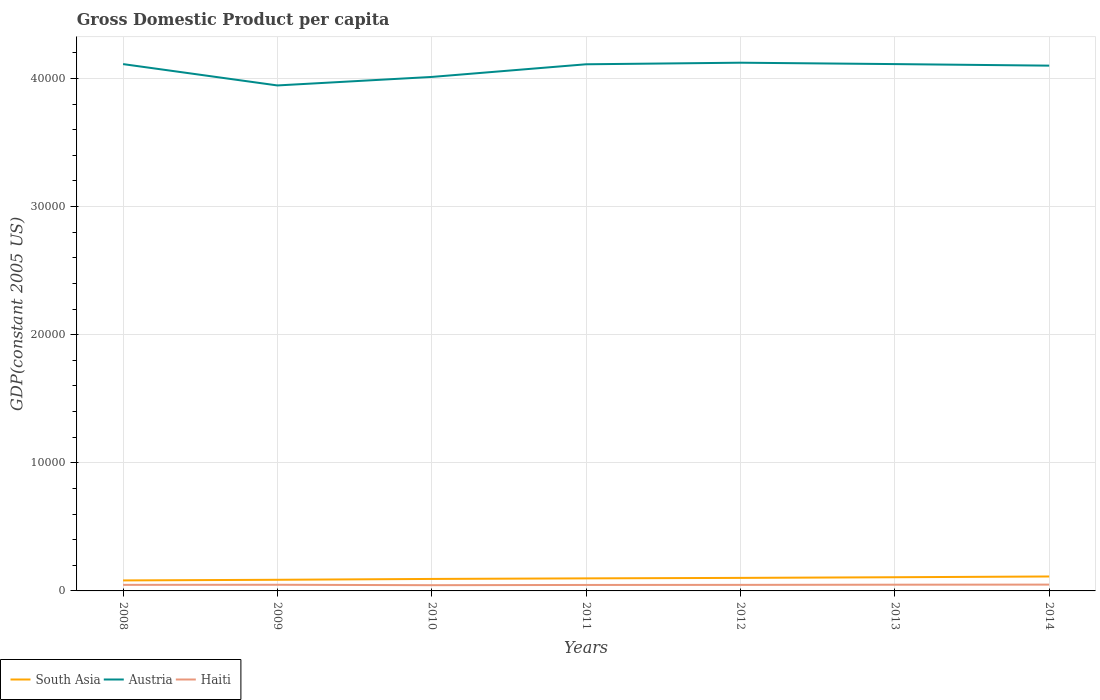Is the number of lines equal to the number of legend labels?
Your response must be concise. Yes. Across all years, what is the maximum GDP per capita in Austria?
Your response must be concise. 3.95e+04. What is the total GDP per capita in Austria in the graph?
Offer a terse response. -1666.59. What is the difference between the highest and the second highest GDP per capita in South Asia?
Your answer should be compact. 306.79. What is the difference between the highest and the lowest GDP per capita in Haiti?
Provide a succinct answer. 3. How many lines are there?
Make the answer very short. 3. Are the values on the major ticks of Y-axis written in scientific E-notation?
Give a very brief answer. No. Does the graph contain grids?
Give a very brief answer. Yes. Where does the legend appear in the graph?
Provide a succinct answer. Bottom left. How many legend labels are there?
Your response must be concise. 3. What is the title of the graph?
Offer a terse response. Gross Domestic Product per capita. Does "Andorra" appear as one of the legend labels in the graph?
Offer a very short reply. No. What is the label or title of the X-axis?
Offer a very short reply. Years. What is the label or title of the Y-axis?
Your response must be concise. GDP(constant 2005 US). What is the GDP(constant 2005 US) in South Asia in 2008?
Offer a very short reply. 819.76. What is the GDP(constant 2005 US) in Austria in 2008?
Ensure brevity in your answer.  4.11e+04. What is the GDP(constant 2005 US) in Haiti in 2008?
Make the answer very short. 473.28. What is the GDP(constant 2005 US) in South Asia in 2009?
Your answer should be compact. 869.5. What is the GDP(constant 2005 US) of Austria in 2009?
Provide a succinct answer. 3.95e+04. What is the GDP(constant 2005 US) of Haiti in 2009?
Provide a short and direct response. 480.56. What is the GDP(constant 2005 US) of South Asia in 2010?
Ensure brevity in your answer.  934.8. What is the GDP(constant 2005 US) in Austria in 2010?
Give a very brief answer. 4.01e+04. What is the GDP(constant 2005 US) of Haiti in 2010?
Your answer should be very brief. 447.47. What is the GDP(constant 2005 US) of South Asia in 2011?
Keep it short and to the point. 979.83. What is the GDP(constant 2005 US) in Austria in 2011?
Provide a short and direct response. 4.11e+04. What is the GDP(constant 2005 US) of Haiti in 2011?
Offer a terse response. 465.43. What is the GDP(constant 2005 US) of South Asia in 2012?
Your answer should be compact. 1016.87. What is the GDP(constant 2005 US) in Austria in 2012?
Your answer should be very brief. 4.12e+04. What is the GDP(constant 2005 US) of Haiti in 2012?
Offer a terse response. 472.16. What is the GDP(constant 2005 US) in South Asia in 2013?
Keep it short and to the point. 1068.23. What is the GDP(constant 2005 US) of Austria in 2013?
Give a very brief answer. 4.11e+04. What is the GDP(constant 2005 US) of Haiti in 2013?
Give a very brief answer. 485.5. What is the GDP(constant 2005 US) of South Asia in 2014?
Offer a very short reply. 1126.55. What is the GDP(constant 2005 US) in Austria in 2014?
Give a very brief answer. 4.10e+04. What is the GDP(constant 2005 US) in Haiti in 2014?
Give a very brief answer. 492.2. Across all years, what is the maximum GDP(constant 2005 US) of South Asia?
Your answer should be compact. 1126.55. Across all years, what is the maximum GDP(constant 2005 US) of Austria?
Make the answer very short. 4.12e+04. Across all years, what is the maximum GDP(constant 2005 US) in Haiti?
Your answer should be very brief. 492.2. Across all years, what is the minimum GDP(constant 2005 US) of South Asia?
Offer a terse response. 819.76. Across all years, what is the minimum GDP(constant 2005 US) in Austria?
Give a very brief answer. 3.95e+04. Across all years, what is the minimum GDP(constant 2005 US) in Haiti?
Ensure brevity in your answer.  447.47. What is the total GDP(constant 2005 US) of South Asia in the graph?
Make the answer very short. 6815.54. What is the total GDP(constant 2005 US) of Austria in the graph?
Offer a very short reply. 2.85e+05. What is the total GDP(constant 2005 US) in Haiti in the graph?
Give a very brief answer. 3316.6. What is the difference between the GDP(constant 2005 US) in South Asia in 2008 and that in 2009?
Offer a very short reply. -49.74. What is the difference between the GDP(constant 2005 US) of Austria in 2008 and that in 2009?
Keep it short and to the point. 1665.68. What is the difference between the GDP(constant 2005 US) of Haiti in 2008 and that in 2009?
Make the answer very short. -7.27. What is the difference between the GDP(constant 2005 US) in South Asia in 2008 and that in 2010?
Ensure brevity in your answer.  -115.04. What is the difference between the GDP(constant 2005 US) of Austria in 2008 and that in 2010?
Offer a terse response. 1001.29. What is the difference between the GDP(constant 2005 US) in Haiti in 2008 and that in 2010?
Ensure brevity in your answer.  25.81. What is the difference between the GDP(constant 2005 US) in South Asia in 2008 and that in 2011?
Provide a succinct answer. -160.07. What is the difference between the GDP(constant 2005 US) in Austria in 2008 and that in 2011?
Offer a terse response. 13.54. What is the difference between the GDP(constant 2005 US) in Haiti in 2008 and that in 2011?
Your response must be concise. 7.85. What is the difference between the GDP(constant 2005 US) of South Asia in 2008 and that in 2012?
Ensure brevity in your answer.  -197.11. What is the difference between the GDP(constant 2005 US) in Austria in 2008 and that in 2012?
Provide a succinct answer. -109.35. What is the difference between the GDP(constant 2005 US) of Haiti in 2008 and that in 2012?
Keep it short and to the point. 1.12. What is the difference between the GDP(constant 2005 US) of South Asia in 2008 and that in 2013?
Your response must be concise. -248.47. What is the difference between the GDP(constant 2005 US) of Austria in 2008 and that in 2013?
Your response must be concise. -0.91. What is the difference between the GDP(constant 2005 US) of Haiti in 2008 and that in 2013?
Offer a terse response. -12.21. What is the difference between the GDP(constant 2005 US) of South Asia in 2008 and that in 2014?
Provide a short and direct response. -306.79. What is the difference between the GDP(constant 2005 US) of Austria in 2008 and that in 2014?
Your response must be concise. 120.24. What is the difference between the GDP(constant 2005 US) of Haiti in 2008 and that in 2014?
Provide a short and direct response. -18.92. What is the difference between the GDP(constant 2005 US) in South Asia in 2009 and that in 2010?
Make the answer very short. -65.31. What is the difference between the GDP(constant 2005 US) in Austria in 2009 and that in 2010?
Keep it short and to the point. -664.39. What is the difference between the GDP(constant 2005 US) in Haiti in 2009 and that in 2010?
Make the answer very short. 33.08. What is the difference between the GDP(constant 2005 US) of South Asia in 2009 and that in 2011?
Your answer should be very brief. -110.34. What is the difference between the GDP(constant 2005 US) of Austria in 2009 and that in 2011?
Ensure brevity in your answer.  -1652.14. What is the difference between the GDP(constant 2005 US) in Haiti in 2009 and that in 2011?
Make the answer very short. 15.13. What is the difference between the GDP(constant 2005 US) in South Asia in 2009 and that in 2012?
Your response must be concise. -147.37. What is the difference between the GDP(constant 2005 US) in Austria in 2009 and that in 2012?
Keep it short and to the point. -1775.04. What is the difference between the GDP(constant 2005 US) in Haiti in 2009 and that in 2012?
Your answer should be very brief. 8.4. What is the difference between the GDP(constant 2005 US) in South Asia in 2009 and that in 2013?
Offer a terse response. -198.73. What is the difference between the GDP(constant 2005 US) in Austria in 2009 and that in 2013?
Give a very brief answer. -1666.59. What is the difference between the GDP(constant 2005 US) of Haiti in 2009 and that in 2013?
Ensure brevity in your answer.  -4.94. What is the difference between the GDP(constant 2005 US) of South Asia in 2009 and that in 2014?
Offer a terse response. -257.05. What is the difference between the GDP(constant 2005 US) in Austria in 2009 and that in 2014?
Keep it short and to the point. -1545.44. What is the difference between the GDP(constant 2005 US) of Haiti in 2009 and that in 2014?
Ensure brevity in your answer.  -11.65. What is the difference between the GDP(constant 2005 US) in South Asia in 2010 and that in 2011?
Offer a very short reply. -45.03. What is the difference between the GDP(constant 2005 US) in Austria in 2010 and that in 2011?
Your answer should be compact. -987.75. What is the difference between the GDP(constant 2005 US) of Haiti in 2010 and that in 2011?
Your response must be concise. -17.96. What is the difference between the GDP(constant 2005 US) in South Asia in 2010 and that in 2012?
Provide a short and direct response. -82.07. What is the difference between the GDP(constant 2005 US) in Austria in 2010 and that in 2012?
Your answer should be very brief. -1110.64. What is the difference between the GDP(constant 2005 US) of Haiti in 2010 and that in 2012?
Ensure brevity in your answer.  -24.68. What is the difference between the GDP(constant 2005 US) of South Asia in 2010 and that in 2013?
Your answer should be very brief. -133.43. What is the difference between the GDP(constant 2005 US) in Austria in 2010 and that in 2013?
Offer a very short reply. -1002.2. What is the difference between the GDP(constant 2005 US) of Haiti in 2010 and that in 2013?
Your answer should be very brief. -38.02. What is the difference between the GDP(constant 2005 US) of South Asia in 2010 and that in 2014?
Offer a very short reply. -191.74. What is the difference between the GDP(constant 2005 US) in Austria in 2010 and that in 2014?
Make the answer very short. -881.05. What is the difference between the GDP(constant 2005 US) in Haiti in 2010 and that in 2014?
Make the answer very short. -44.73. What is the difference between the GDP(constant 2005 US) in South Asia in 2011 and that in 2012?
Offer a terse response. -37.03. What is the difference between the GDP(constant 2005 US) in Austria in 2011 and that in 2012?
Give a very brief answer. -122.9. What is the difference between the GDP(constant 2005 US) in Haiti in 2011 and that in 2012?
Keep it short and to the point. -6.73. What is the difference between the GDP(constant 2005 US) of South Asia in 2011 and that in 2013?
Make the answer very short. -88.4. What is the difference between the GDP(constant 2005 US) in Austria in 2011 and that in 2013?
Ensure brevity in your answer.  -14.45. What is the difference between the GDP(constant 2005 US) of Haiti in 2011 and that in 2013?
Your response must be concise. -20.07. What is the difference between the GDP(constant 2005 US) of South Asia in 2011 and that in 2014?
Your response must be concise. -146.71. What is the difference between the GDP(constant 2005 US) of Austria in 2011 and that in 2014?
Keep it short and to the point. 106.7. What is the difference between the GDP(constant 2005 US) in Haiti in 2011 and that in 2014?
Provide a short and direct response. -26.77. What is the difference between the GDP(constant 2005 US) in South Asia in 2012 and that in 2013?
Offer a very short reply. -51.36. What is the difference between the GDP(constant 2005 US) of Austria in 2012 and that in 2013?
Ensure brevity in your answer.  108.44. What is the difference between the GDP(constant 2005 US) of Haiti in 2012 and that in 2013?
Provide a succinct answer. -13.34. What is the difference between the GDP(constant 2005 US) of South Asia in 2012 and that in 2014?
Keep it short and to the point. -109.68. What is the difference between the GDP(constant 2005 US) of Austria in 2012 and that in 2014?
Provide a short and direct response. 229.6. What is the difference between the GDP(constant 2005 US) of Haiti in 2012 and that in 2014?
Offer a very short reply. -20.04. What is the difference between the GDP(constant 2005 US) in South Asia in 2013 and that in 2014?
Offer a very short reply. -58.32. What is the difference between the GDP(constant 2005 US) in Austria in 2013 and that in 2014?
Your response must be concise. 121.15. What is the difference between the GDP(constant 2005 US) in Haiti in 2013 and that in 2014?
Provide a short and direct response. -6.71. What is the difference between the GDP(constant 2005 US) of South Asia in 2008 and the GDP(constant 2005 US) of Austria in 2009?
Provide a succinct answer. -3.86e+04. What is the difference between the GDP(constant 2005 US) in South Asia in 2008 and the GDP(constant 2005 US) in Haiti in 2009?
Keep it short and to the point. 339.21. What is the difference between the GDP(constant 2005 US) of Austria in 2008 and the GDP(constant 2005 US) of Haiti in 2009?
Ensure brevity in your answer.  4.06e+04. What is the difference between the GDP(constant 2005 US) in South Asia in 2008 and the GDP(constant 2005 US) in Austria in 2010?
Your answer should be very brief. -3.93e+04. What is the difference between the GDP(constant 2005 US) in South Asia in 2008 and the GDP(constant 2005 US) in Haiti in 2010?
Offer a terse response. 372.29. What is the difference between the GDP(constant 2005 US) of Austria in 2008 and the GDP(constant 2005 US) of Haiti in 2010?
Make the answer very short. 4.07e+04. What is the difference between the GDP(constant 2005 US) of South Asia in 2008 and the GDP(constant 2005 US) of Austria in 2011?
Your response must be concise. -4.03e+04. What is the difference between the GDP(constant 2005 US) in South Asia in 2008 and the GDP(constant 2005 US) in Haiti in 2011?
Make the answer very short. 354.33. What is the difference between the GDP(constant 2005 US) in Austria in 2008 and the GDP(constant 2005 US) in Haiti in 2011?
Keep it short and to the point. 4.07e+04. What is the difference between the GDP(constant 2005 US) of South Asia in 2008 and the GDP(constant 2005 US) of Austria in 2012?
Your response must be concise. -4.04e+04. What is the difference between the GDP(constant 2005 US) of South Asia in 2008 and the GDP(constant 2005 US) of Haiti in 2012?
Offer a terse response. 347.6. What is the difference between the GDP(constant 2005 US) of Austria in 2008 and the GDP(constant 2005 US) of Haiti in 2012?
Provide a short and direct response. 4.06e+04. What is the difference between the GDP(constant 2005 US) of South Asia in 2008 and the GDP(constant 2005 US) of Austria in 2013?
Offer a terse response. -4.03e+04. What is the difference between the GDP(constant 2005 US) in South Asia in 2008 and the GDP(constant 2005 US) in Haiti in 2013?
Make the answer very short. 334.27. What is the difference between the GDP(constant 2005 US) in Austria in 2008 and the GDP(constant 2005 US) in Haiti in 2013?
Offer a terse response. 4.06e+04. What is the difference between the GDP(constant 2005 US) in South Asia in 2008 and the GDP(constant 2005 US) in Austria in 2014?
Offer a very short reply. -4.02e+04. What is the difference between the GDP(constant 2005 US) of South Asia in 2008 and the GDP(constant 2005 US) of Haiti in 2014?
Make the answer very short. 327.56. What is the difference between the GDP(constant 2005 US) of Austria in 2008 and the GDP(constant 2005 US) of Haiti in 2014?
Offer a very short reply. 4.06e+04. What is the difference between the GDP(constant 2005 US) of South Asia in 2009 and the GDP(constant 2005 US) of Austria in 2010?
Offer a terse response. -3.92e+04. What is the difference between the GDP(constant 2005 US) of South Asia in 2009 and the GDP(constant 2005 US) of Haiti in 2010?
Provide a short and direct response. 422.02. What is the difference between the GDP(constant 2005 US) of Austria in 2009 and the GDP(constant 2005 US) of Haiti in 2010?
Make the answer very short. 3.90e+04. What is the difference between the GDP(constant 2005 US) of South Asia in 2009 and the GDP(constant 2005 US) of Austria in 2011?
Keep it short and to the point. -4.02e+04. What is the difference between the GDP(constant 2005 US) of South Asia in 2009 and the GDP(constant 2005 US) of Haiti in 2011?
Provide a short and direct response. 404.07. What is the difference between the GDP(constant 2005 US) in Austria in 2009 and the GDP(constant 2005 US) in Haiti in 2011?
Offer a very short reply. 3.90e+04. What is the difference between the GDP(constant 2005 US) of South Asia in 2009 and the GDP(constant 2005 US) of Austria in 2012?
Keep it short and to the point. -4.04e+04. What is the difference between the GDP(constant 2005 US) of South Asia in 2009 and the GDP(constant 2005 US) of Haiti in 2012?
Your response must be concise. 397.34. What is the difference between the GDP(constant 2005 US) in Austria in 2009 and the GDP(constant 2005 US) in Haiti in 2012?
Your answer should be compact. 3.90e+04. What is the difference between the GDP(constant 2005 US) of South Asia in 2009 and the GDP(constant 2005 US) of Austria in 2013?
Ensure brevity in your answer.  -4.03e+04. What is the difference between the GDP(constant 2005 US) in South Asia in 2009 and the GDP(constant 2005 US) in Haiti in 2013?
Provide a short and direct response. 384. What is the difference between the GDP(constant 2005 US) of Austria in 2009 and the GDP(constant 2005 US) of Haiti in 2013?
Keep it short and to the point. 3.90e+04. What is the difference between the GDP(constant 2005 US) in South Asia in 2009 and the GDP(constant 2005 US) in Austria in 2014?
Provide a succinct answer. -4.01e+04. What is the difference between the GDP(constant 2005 US) in South Asia in 2009 and the GDP(constant 2005 US) in Haiti in 2014?
Your response must be concise. 377.29. What is the difference between the GDP(constant 2005 US) in Austria in 2009 and the GDP(constant 2005 US) in Haiti in 2014?
Provide a short and direct response. 3.90e+04. What is the difference between the GDP(constant 2005 US) of South Asia in 2010 and the GDP(constant 2005 US) of Austria in 2011?
Provide a succinct answer. -4.02e+04. What is the difference between the GDP(constant 2005 US) in South Asia in 2010 and the GDP(constant 2005 US) in Haiti in 2011?
Your response must be concise. 469.37. What is the difference between the GDP(constant 2005 US) of Austria in 2010 and the GDP(constant 2005 US) of Haiti in 2011?
Your answer should be very brief. 3.97e+04. What is the difference between the GDP(constant 2005 US) in South Asia in 2010 and the GDP(constant 2005 US) in Austria in 2012?
Make the answer very short. -4.03e+04. What is the difference between the GDP(constant 2005 US) in South Asia in 2010 and the GDP(constant 2005 US) in Haiti in 2012?
Make the answer very short. 462.64. What is the difference between the GDP(constant 2005 US) of Austria in 2010 and the GDP(constant 2005 US) of Haiti in 2012?
Offer a terse response. 3.96e+04. What is the difference between the GDP(constant 2005 US) of South Asia in 2010 and the GDP(constant 2005 US) of Austria in 2013?
Make the answer very short. -4.02e+04. What is the difference between the GDP(constant 2005 US) of South Asia in 2010 and the GDP(constant 2005 US) of Haiti in 2013?
Provide a short and direct response. 449.31. What is the difference between the GDP(constant 2005 US) in Austria in 2010 and the GDP(constant 2005 US) in Haiti in 2013?
Offer a terse response. 3.96e+04. What is the difference between the GDP(constant 2005 US) of South Asia in 2010 and the GDP(constant 2005 US) of Austria in 2014?
Provide a short and direct response. -4.01e+04. What is the difference between the GDP(constant 2005 US) of South Asia in 2010 and the GDP(constant 2005 US) of Haiti in 2014?
Give a very brief answer. 442.6. What is the difference between the GDP(constant 2005 US) of Austria in 2010 and the GDP(constant 2005 US) of Haiti in 2014?
Keep it short and to the point. 3.96e+04. What is the difference between the GDP(constant 2005 US) of South Asia in 2011 and the GDP(constant 2005 US) of Austria in 2012?
Ensure brevity in your answer.  -4.02e+04. What is the difference between the GDP(constant 2005 US) in South Asia in 2011 and the GDP(constant 2005 US) in Haiti in 2012?
Ensure brevity in your answer.  507.68. What is the difference between the GDP(constant 2005 US) in Austria in 2011 and the GDP(constant 2005 US) in Haiti in 2012?
Provide a short and direct response. 4.06e+04. What is the difference between the GDP(constant 2005 US) in South Asia in 2011 and the GDP(constant 2005 US) in Austria in 2013?
Keep it short and to the point. -4.01e+04. What is the difference between the GDP(constant 2005 US) in South Asia in 2011 and the GDP(constant 2005 US) in Haiti in 2013?
Offer a very short reply. 494.34. What is the difference between the GDP(constant 2005 US) in Austria in 2011 and the GDP(constant 2005 US) in Haiti in 2013?
Your answer should be very brief. 4.06e+04. What is the difference between the GDP(constant 2005 US) in South Asia in 2011 and the GDP(constant 2005 US) in Austria in 2014?
Provide a short and direct response. -4.00e+04. What is the difference between the GDP(constant 2005 US) in South Asia in 2011 and the GDP(constant 2005 US) in Haiti in 2014?
Make the answer very short. 487.63. What is the difference between the GDP(constant 2005 US) of Austria in 2011 and the GDP(constant 2005 US) of Haiti in 2014?
Ensure brevity in your answer.  4.06e+04. What is the difference between the GDP(constant 2005 US) in South Asia in 2012 and the GDP(constant 2005 US) in Austria in 2013?
Keep it short and to the point. -4.01e+04. What is the difference between the GDP(constant 2005 US) in South Asia in 2012 and the GDP(constant 2005 US) in Haiti in 2013?
Offer a terse response. 531.37. What is the difference between the GDP(constant 2005 US) in Austria in 2012 and the GDP(constant 2005 US) in Haiti in 2013?
Make the answer very short. 4.07e+04. What is the difference between the GDP(constant 2005 US) in South Asia in 2012 and the GDP(constant 2005 US) in Austria in 2014?
Keep it short and to the point. -4.00e+04. What is the difference between the GDP(constant 2005 US) in South Asia in 2012 and the GDP(constant 2005 US) in Haiti in 2014?
Keep it short and to the point. 524.67. What is the difference between the GDP(constant 2005 US) of Austria in 2012 and the GDP(constant 2005 US) of Haiti in 2014?
Your answer should be very brief. 4.07e+04. What is the difference between the GDP(constant 2005 US) of South Asia in 2013 and the GDP(constant 2005 US) of Austria in 2014?
Provide a succinct answer. -3.99e+04. What is the difference between the GDP(constant 2005 US) of South Asia in 2013 and the GDP(constant 2005 US) of Haiti in 2014?
Provide a short and direct response. 576.03. What is the difference between the GDP(constant 2005 US) in Austria in 2013 and the GDP(constant 2005 US) in Haiti in 2014?
Offer a terse response. 4.06e+04. What is the average GDP(constant 2005 US) in South Asia per year?
Offer a very short reply. 973.65. What is the average GDP(constant 2005 US) of Austria per year?
Ensure brevity in your answer.  4.07e+04. What is the average GDP(constant 2005 US) in Haiti per year?
Your response must be concise. 473.8. In the year 2008, what is the difference between the GDP(constant 2005 US) of South Asia and GDP(constant 2005 US) of Austria?
Your response must be concise. -4.03e+04. In the year 2008, what is the difference between the GDP(constant 2005 US) in South Asia and GDP(constant 2005 US) in Haiti?
Offer a terse response. 346.48. In the year 2008, what is the difference between the GDP(constant 2005 US) in Austria and GDP(constant 2005 US) in Haiti?
Offer a very short reply. 4.06e+04. In the year 2009, what is the difference between the GDP(constant 2005 US) of South Asia and GDP(constant 2005 US) of Austria?
Offer a terse response. -3.86e+04. In the year 2009, what is the difference between the GDP(constant 2005 US) of South Asia and GDP(constant 2005 US) of Haiti?
Keep it short and to the point. 388.94. In the year 2009, what is the difference between the GDP(constant 2005 US) of Austria and GDP(constant 2005 US) of Haiti?
Offer a very short reply. 3.90e+04. In the year 2010, what is the difference between the GDP(constant 2005 US) in South Asia and GDP(constant 2005 US) in Austria?
Give a very brief answer. -3.92e+04. In the year 2010, what is the difference between the GDP(constant 2005 US) of South Asia and GDP(constant 2005 US) of Haiti?
Give a very brief answer. 487.33. In the year 2010, what is the difference between the GDP(constant 2005 US) in Austria and GDP(constant 2005 US) in Haiti?
Your answer should be very brief. 3.97e+04. In the year 2011, what is the difference between the GDP(constant 2005 US) in South Asia and GDP(constant 2005 US) in Austria?
Provide a succinct answer. -4.01e+04. In the year 2011, what is the difference between the GDP(constant 2005 US) in South Asia and GDP(constant 2005 US) in Haiti?
Make the answer very short. 514.4. In the year 2011, what is the difference between the GDP(constant 2005 US) in Austria and GDP(constant 2005 US) in Haiti?
Give a very brief answer. 4.06e+04. In the year 2012, what is the difference between the GDP(constant 2005 US) of South Asia and GDP(constant 2005 US) of Austria?
Provide a succinct answer. -4.02e+04. In the year 2012, what is the difference between the GDP(constant 2005 US) in South Asia and GDP(constant 2005 US) in Haiti?
Provide a succinct answer. 544.71. In the year 2012, what is the difference between the GDP(constant 2005 US) of Austria and GDP(constant 2005 US) of Haiti?
Keep it short and to the point. 4.08e+04. In the year 2013, what is the difference between the GDP(constant 2005 US) of South Asia and GDP(constant 2005 US) of Austria?
Your answer should be very brief. -4.01e+04. In the year 2013, what is the difference between the GDP(constant 2005 US) in South Asia and GDP(constant 2005 US) in Haiti?
Keep it short and to the point. 582.74. In the year 2013, what is the difference between the GDP(constant 2005 US) in Austria and GDP(constant 2005 US) in Haiti?
Provide a short and direct response. 4.06e+04. In the year 2014, what is the difference between the GDP(constant 2005 US) in South Asia and GDP(constant 2005 US) in Austria?
Make the answer very short. -3.99e+04. In the year 2014, what is the difference between the GDP(constant 2005 US) of South Asia and GDP(constant 2005 US) of Haiti?
Offer a terse response. 634.34. In the year 2014, what is the difference between the GDP(constant 2005 US) in Austria and GDP(constant 2005 US) in Haiti?
Offer a very short reply. 4.05e+04. What is the ratio of the GDP(constant 2005 US) of South Asia in 2008 to that in 2009?
Your answer should be very brief. 0.94. What is the ratio of the GDP(constant 2005 US) of Austria in 2008 to that in 2009?
Ensure brevity in your answer.  1.04. What is the ratio of the GDP(constant 2005 US) in Haiti in 2008 to that in 2009?
Offer a very short reply. 0.98. What is the ratio of the GDP(constant 2005 US) of South Asia in 2008 to that in 2010?
Your response must be concise. 0.88. What is the ratio of the GDP(constant 2005 US) in Austria in 2008 to that in 2010?
Your answer should be very brief. 1.02. What is the ratio of the GDP(constant 2005 US) of Haiti in 2008 to that in 2010?
Offer a very short reply. 1.06. What is the ratio of the GDP(constant 2005 US) of South Asia in 2008 to that in 2011?
Your answer should be compact. 0.84. What is the ratio of the GDP(constant 2005 US) in Austria in 2008 to that in 2011?
Give a very brief answer. 1. What is the ratio of the GDP(constant 2005 US) of Haiti in 2008 to that in 2011?
Offer a terse response. 1.02. What is the ratio of the GDP(constant 2005 US) of South Asia in 2008 to that in 2012?
Offer a terse response. 0.81. What is the ratio of the GDP(constant 2005 US) in Haiti in 2008 to that in 2012?
Provide a succinct answer. 1. What is the ratio of the GDP(constant 2005 US) in South Asia in 2008 to that in 2013?
Your answer should be very brief. 0.77. What is the ratio of the GDP(constant 2005 US) of Haiti in 2008 to that in 2013?
Give a very brief answer. 0.97. What is the ratio of the GDP(constant 2005 US) in South Asia in 2008 to that in 2014?
Your response must be concise. 0.73. What is the ratio of the GDP(constant 2005 US) of Haiti in 2008 to that in 2014?
Offer a terse response. 0.96. What is the ratio of the GDP(constant 2005 US) in South Asia in 2009 to that in 2010?
Ensure brevity in your answer.  0.93. What is the ratio of the GDP(constant 2005 US) in Austria in 2009 to that in 2010?
Make the answer very short. 0.98. What is the ratio of the GDP(constant 2005 US) in Haiti in 2009 to that in 2010?
Provide a short and direct response. 1.07. What is the ratio of the GDP(constant 2005 US) in South Asia in 2009 to that in 2011?
Your response must be concise. 0.89. What is the ratio of the GDP(constant 2005 US) in Austria in 2009 to that in 2011?
Keep it short and to the point. 0.96. What is the ratio of the GDP(constant 2005 US) of Haiti in 2009 to that in 2011?
Offer a terse response. 1.03. What is the ratio of the GDP(constant 2005 US) in South Asia in 2009 to that in 2012?
Ensure brevity in your answer.  0.86. What is the ratio of the GDP(constant 2005 US) of Austria in 2009 to that in 2012?
Offer a terse response. 0.96. What is the ratio of the GDP(constant 2005 US) in Haiti in 2009 to that in 2012?
Offer a very short reply. 1.02. What is the ratio of the GDP(constant 2005 US) of South Asia in 2009 to that in 2013?
Ensure brevity in your answer.  0.81. What is the ratio of the GDP(constant 2005 US) in Austria in 2009 to that in 2013?
Your response must be concise. 0.96. What is the ratio of the GDP(constant 2005 US) of Haiti in 2009 to that in 2013?
Your response must be concise. 0.99. What is the ratio of the GDP(constant 2005 US) in South Asia in 2009 to that in 2014?
Provide a succinct answer. 0.77. What is the ratio of the GDP(constant 2005 US) of Austria in 2009 to that in 2014?
Offer a terse response. 0.96. What is the ratio of the GDP(constant 2005 US) in Haiti in 2009 to that in 2014?
Give a very brief answer. 0.98. What is the ratio of the GDP(constant 2005 US) in South Asia in 2010 to that in 2011?
Provide a succinct answer. 0.95. What is the ratio of the GDP(constant 2005 US) of Haiti in 2010 to that in 2011?
Offer a very short reply. 0.96. What is the ratio of the GDP(constant 2005 US) in South Asia in 2010 to that in 2012?
Offer a terse response. 0.92. What is the ratio of the GDP(constant 2005 US) of Austria in 2010 to that in 2012?
Ensure brevity in your answer.  0.97. What is the ratio of the GDP(constant 2005 US) in Haiti in 2010 to that in 2012?
Give a very brief answer. 0.95. What is the ratio of the GDP(constant 2005 US) in South Asia in 2010 to that in 2013?
Provide a succinct answer. 0.88. What is the ratio of the GDP(constant 2005 US) of Austria in 2010 to that in 2013?
Ensure brevity in your answer.  0.98. What is the ratio of the GDP(constant 2005 US) in Haiti in 2010 to that in 2013?
Provide a short and direct response. 0.92. What is the ratio of the GDP(constant 2005 US) in South Asia in 2010 to that in 2014?
Make the answer very short. 0.83. What is the ratio of the GDP(constant 2005 US) in Austria in 2010 to that in 2014?
Provide a succinct answer. 0.98. What is the ratio of the GDP(constant 2005 US) of Haiti in 2010 to that in 2014?
Provide a succinct answer. 0.91. What is the ratio of the GDP(constant 2005 US) of South Asia in 2011 to that in 2012?
Keep it short and to the point. 0.96. What is the ratio of the GDP(constant 2005 US) of Haiti in 2011 to that in 2012?
Provide a succinct answer. 0.99. What is the ratio of the GDP(constant 2005 US) in South Asia in 2011 to that in 2013?
Ensure brevity in your answer.  0.92. What is the ratio of the GDP(constant 2005 US) of Austria in 2011 to that in 2013?
Keep it short and to the point. 1. What is the ratio of the GDP(constant 2005 US) in Haiti in 2011 to that in 2013?
Provide a short and direct response. 0.96. What is the ratio of the GDP(constant 2005 US) in South Asia in 2011 to that in 2014?
Your response must be concise. 0.87. What is the ratio of the GDP(constant 2005 US) of Austria in 2011 to that in 2014?
Your answer should be compact. 1. What is the ratio of the GDP(constant 2005 US) in Haiti in 2011 to that in 2014?
Ensure brevity in your answer.  0.95. What is the ratio of the GDP(constant 2005 US) in South Asia in 2012 to that in 2013?
Keep it short and to the point. 0.95. What is the ratio of the GDP(constant 2005 US) in Haiti in 2012 to that in 2013?
Ensure brevity in your answer.  0.97. What is the ratio of the GDP(constant 2005 US) in South Asia in 2012 to that in 2014?
Make the answer very short. 0.9. What is the ratio of the GDP(constant 2005 US) of Austria in 2012 to that in 2014?
Your answer should be compact. 1.01. What is the ratio of the GDP(constant 2005 US) of Haiti in 2012 to that in 2014?
Offer a very short reply. 0.96. What is the ratio of the GDP(constant 2005 US) in South Asia in 2013 to that in 2014?
Keep it short and to the point. 0.95. What is the ratio of the GDP(constant 2005 US) in Haiti in 2013 to that in 2014?
Provide a short and direct response. 0.99. What is the difference between the highest and the second highest GDP(constant 2005 US) in South Asia?
Make the answer very short. 58.32. What is the difference between the highest and the second highest GDP(constant 2005 US) of Austria?
Ensure brevity in your answer.  108.44. What is the difference between the highest and the second highest GDP(constant 2005 US) in Haiti?
Offer a very short reply. 6.71. What is the difference between the highest and the lowest GDP(constant 2005 US) in South Asia?
Offer a very short reply. 306.79. What is the difference between the highest and the lowest GDP(constant 2005 US) of Austria?
Ensure brevity in your answer.  1775.04. What is the difference between the highest and the lowest GDP(constant 2005 US) in Haiti?
Your answer should be very brief. 44.73. 